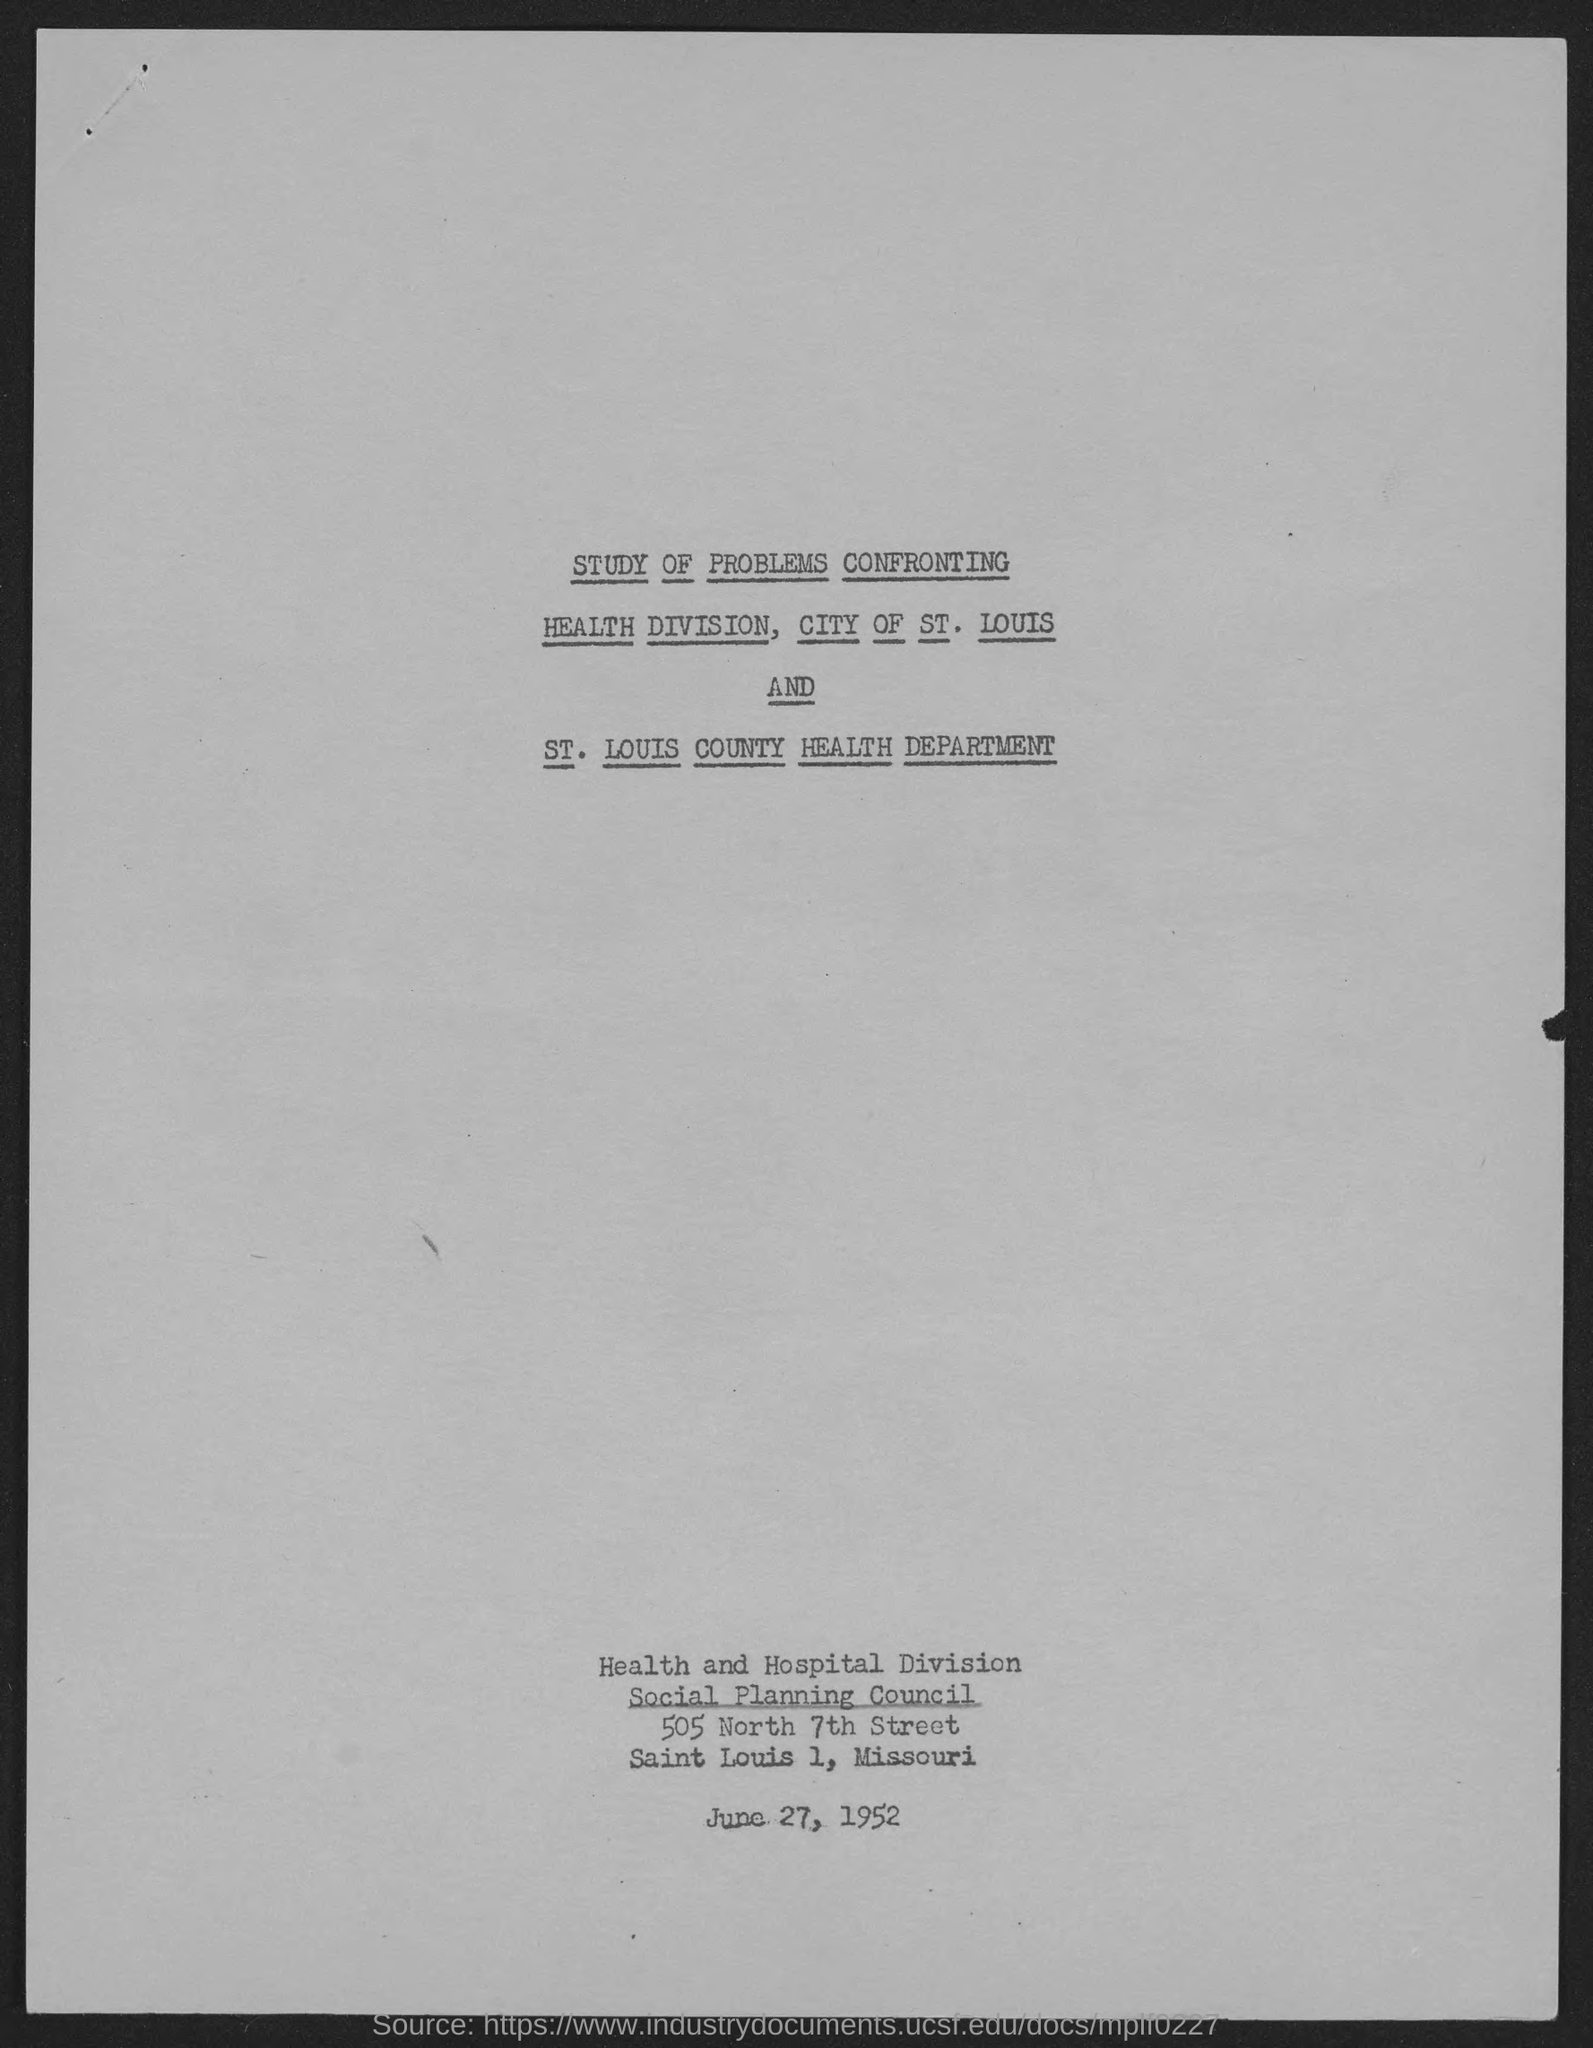Mention a couple of crucial points in this snapshot. The document is dated June 27, 1952. 